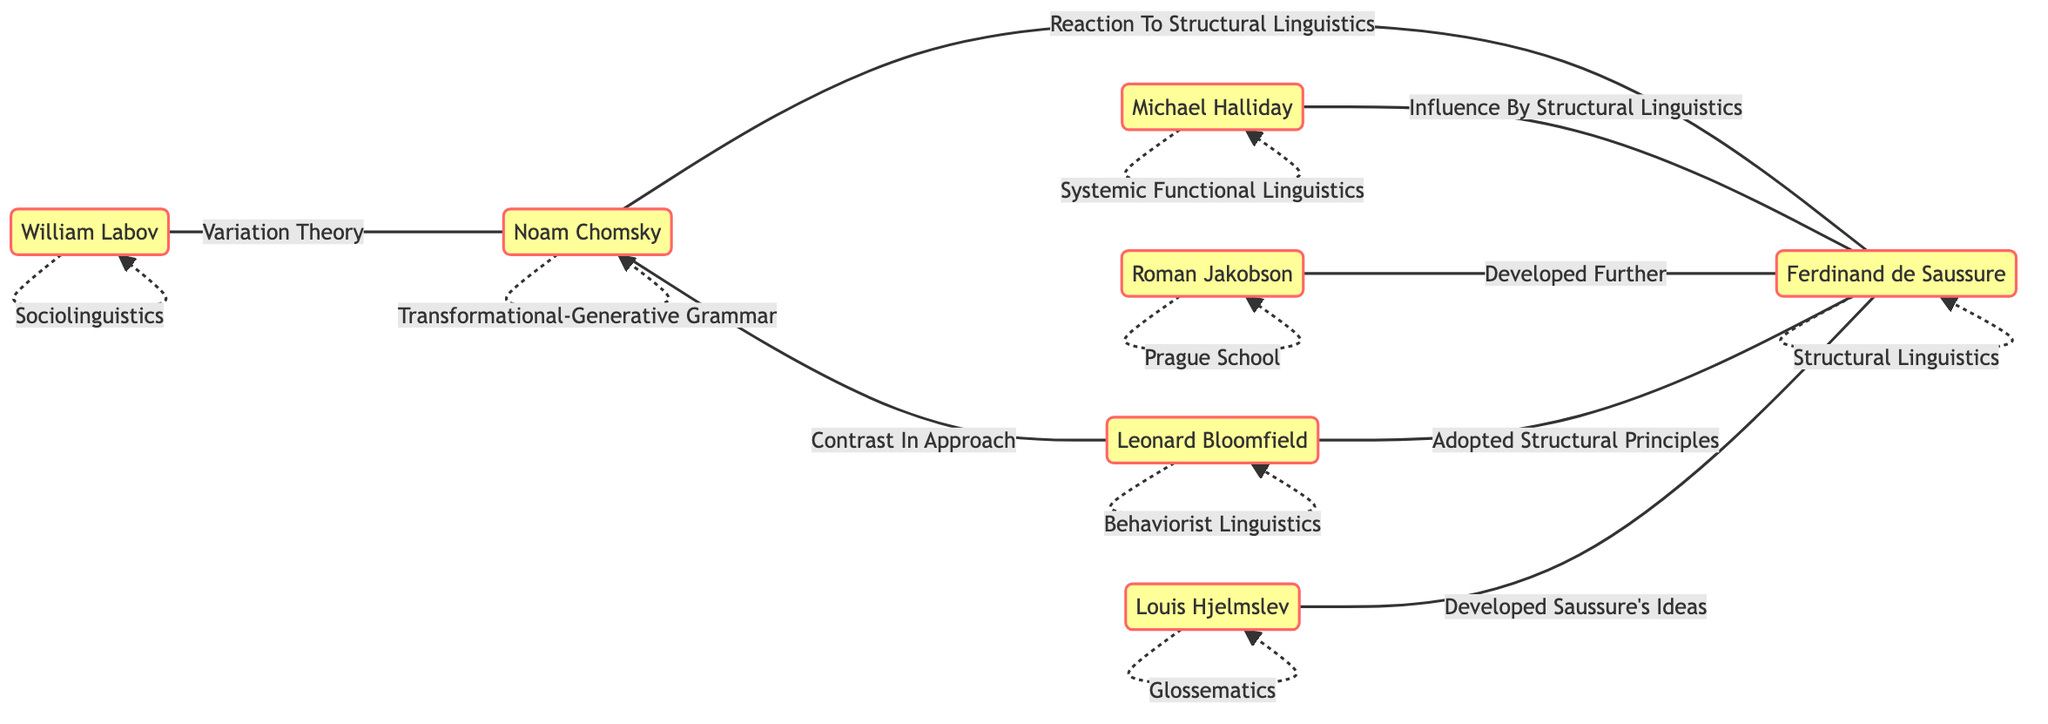What label is associated with Noam Chomsky? The diagram shows a label directly connected to Noam Chomsky, which is "Transformational-Generative Grammar."
Answer: Transformational-Generative Grammar How many edges are found in the diagram? By counting the connections listed between the nodes, there are a total of 7 edges in the diagram.
Answer: 7 Who is linked to Ferdinand de Saussure with the label "Developed Further"? The edge connected to Ferdinand de Saussure with the label "Developed Further" points to Roman Jakobson.
Answer: Roman Jakobson What is the relationship between William Labov and Noam Chomsky? The diagram indicates that there is a specific edge between William Labov and Noam Chomsky labelled "Variation Theory," which defines their relationship.
Answer: Variation Theory Which founder adopted the structural principles of Ferdinand de Saussure? The diagram shows that Leonard Bloomfield has an edge pointing to Ferdinand de Saussure with the label "Adopted Structural Principles."
Answer: Leonard Bloomfield Who had a contrast in approach with Noam Chomsky? The connections indicate that there is an edge from Noam Chomsky leading to Leonard Bloomfield, labelled "Contrast In Approach," suggesting the contrasting relationship.
Answer: Leonard Bloomfield How did Michael Halliday influence Ferdinand de Saussure's ideas? According to the diagram, Michael Halliday is directly connected to Ferdinand de Saussure with the label "Influence By Structural Linguistics," indicating how Halliday was influenced by Saussure's ideas.
Answer: Influence By Structural Linguistics What type of linguistics is associated with Louis Hjelmslev? The diagram specifies that Louis Hjelmslev is related to the label "Glossematics," which is the linguistic theory he is associated with.
Answer: Glossematics Which two founders are connected through a reaction to structural linguistics? The edge between Noam Chomsky and Ferdinand de Saussure labelled "Reaction To Structural Linguistics" shows that these two founders are interconnected in that way.
Answer: Noam Chomsky and Ferdinand de Saussure 